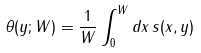Convert formula to latex. <formula><loc_0><loc_0><loc_500><loc_500>\theta ( y ; W ) = \frac { 1 } { W } \int _ { 0 } ^ { W } d x \, s ( x , y )</formula> 